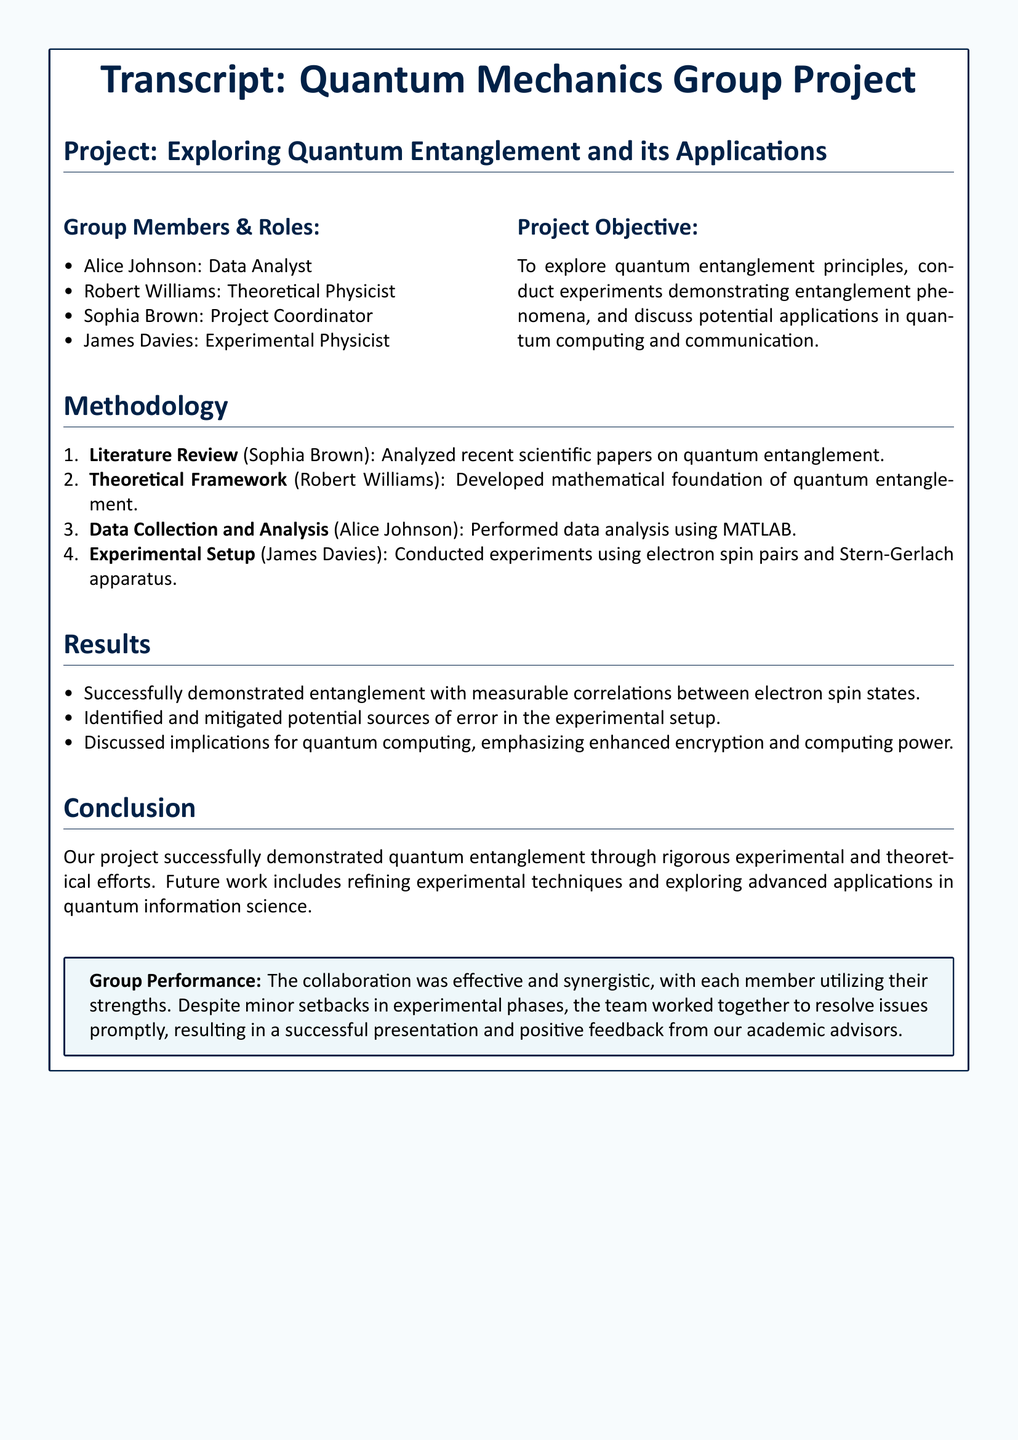What is the project title? The title of the project is provided at the beginning of the transcript, specific to the project details.
Answer: Exploring Quantum Entanglement and its Applications Who was the project coordinator? The transcript lists team members and their roles, explicitly naming each member's position.
Answer: Sophia Brown Which method was used for data analysis? The methodology section specifies the tools and methods used by team members for data analysis.
Answer: MATLAB What successful demonstration is mentioned? The results section summarizes the outcomes of the experiments conducted during the project.
Answer: Entanglement with measurable correlations What future work is suggested in the conclusion? The conclusion outlines further steps that the group intends to take following the initial findings.
Answer: Refining experimental techniques How did the group perform overall? The document includes a specific assessment of the group's collaboration and effectiveness during the project.
Answer: Effective and synergistic What was James Davies's role in the project? The roles of each group member are listed, indicating their specific contributions to the project.
Answer: Experimental Physicist What potential applications were discussed? The results section indicates applications related to the findings and their implications for future technology.
Answer: Quantum computing and communication 